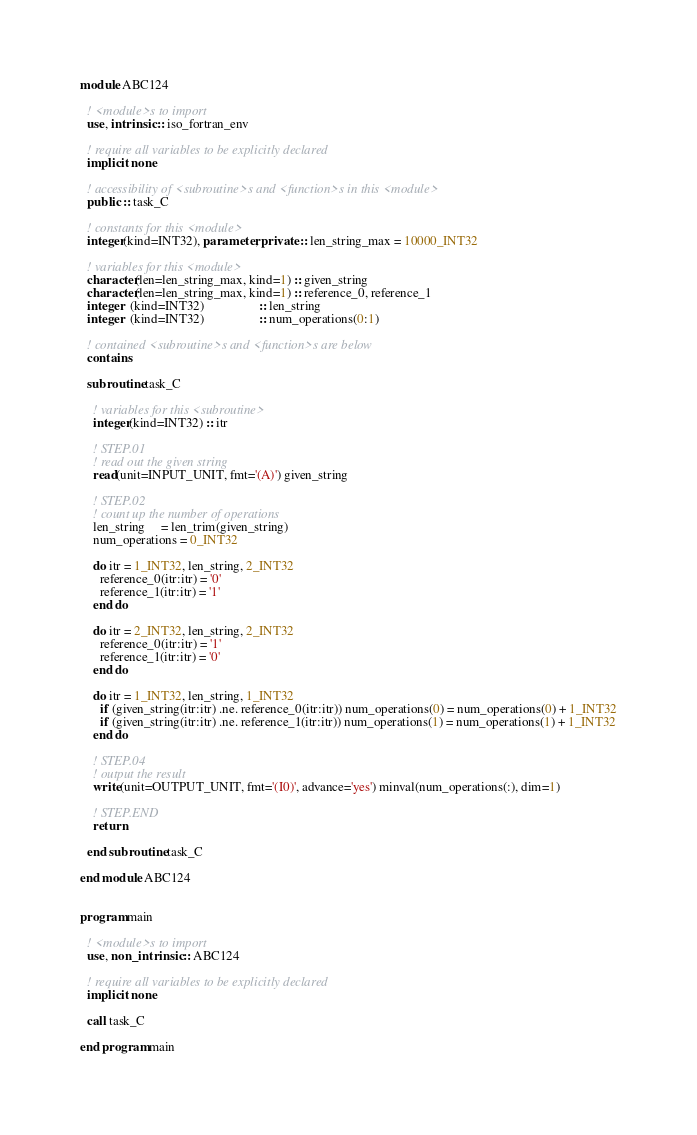<code> <loc_0><loc_0><loc_500><loc_500><_FORTRAN_>module ABC124

  ! <module>s to import
  use, intrinsic :: iso_fortran_env

  ! require all variables to be explicitly declared
  implicit none

  ! accessibility of <subroutine>s and <function>s in this <module>
  public :: task_C

  ! constants for this <module>
  integer(kind=INT32), parameter, private :: len_string_max = 10000_INT32

  ! variables for this <module>
  character(len=len_string_max, kind=1) :: given_string
  character(len=len_string_max, kind=1) :: reference_0, reference_1
  integer  (kind=INT32)                 :: len_string
  integer  (kind=INT32)                 :: num_operations(0:1)

  ! contained <subroutine>s and <function>s are below
  contains

  subroutine task_C

    ! variables for this <subroutine>
    integer(kind=INT32) :: itr

    ! STEP.01
    ! read out the given string
    read(unit=INPUT_UNIT, fmt='(A)') given_string

    ! STEP.02
    ! count up the number of operations
    len_string     = len_trim(given_string)
    num_operations = 0_INT32

    do itr = 1_INT32, len_string, 2_INT32
      reference_0(itr:itr) = '0'
      reference_1(itr:itr) = '1'
    end do

    do itr = 2_INT32, len_string, 2_INT32
      reference_0(itr:itr) = '1'
      reference_1(itr:itr) = '0'
    end do

    do itr = 1_INT32, len_string, 1_INT32
      if (given_string(itr:itr) .ne. reference_0(itr:itr)) num_operations(0) = num_operations(0) + 1_INT32
      if (given_string(itr:itr) .ne. reference_1(itr:itr)) num_operations(1) = num_operations(1) + 1_INT32
    end do

    ! STEP.04
    ! output the result
    write(unit=OUTPUT_UNIT, fmt='(I0)', advance='yes') minval(num_operations(:), dim=1)

    ! STEP.END
    return

  end subroutine task_C

end module ABC124


program main

  ! <module>s to import
  use, non_intrinsic :: ABC124

  ! require all variables to be explicitly declared
  implicit none

  call task_C

end program main</code> 